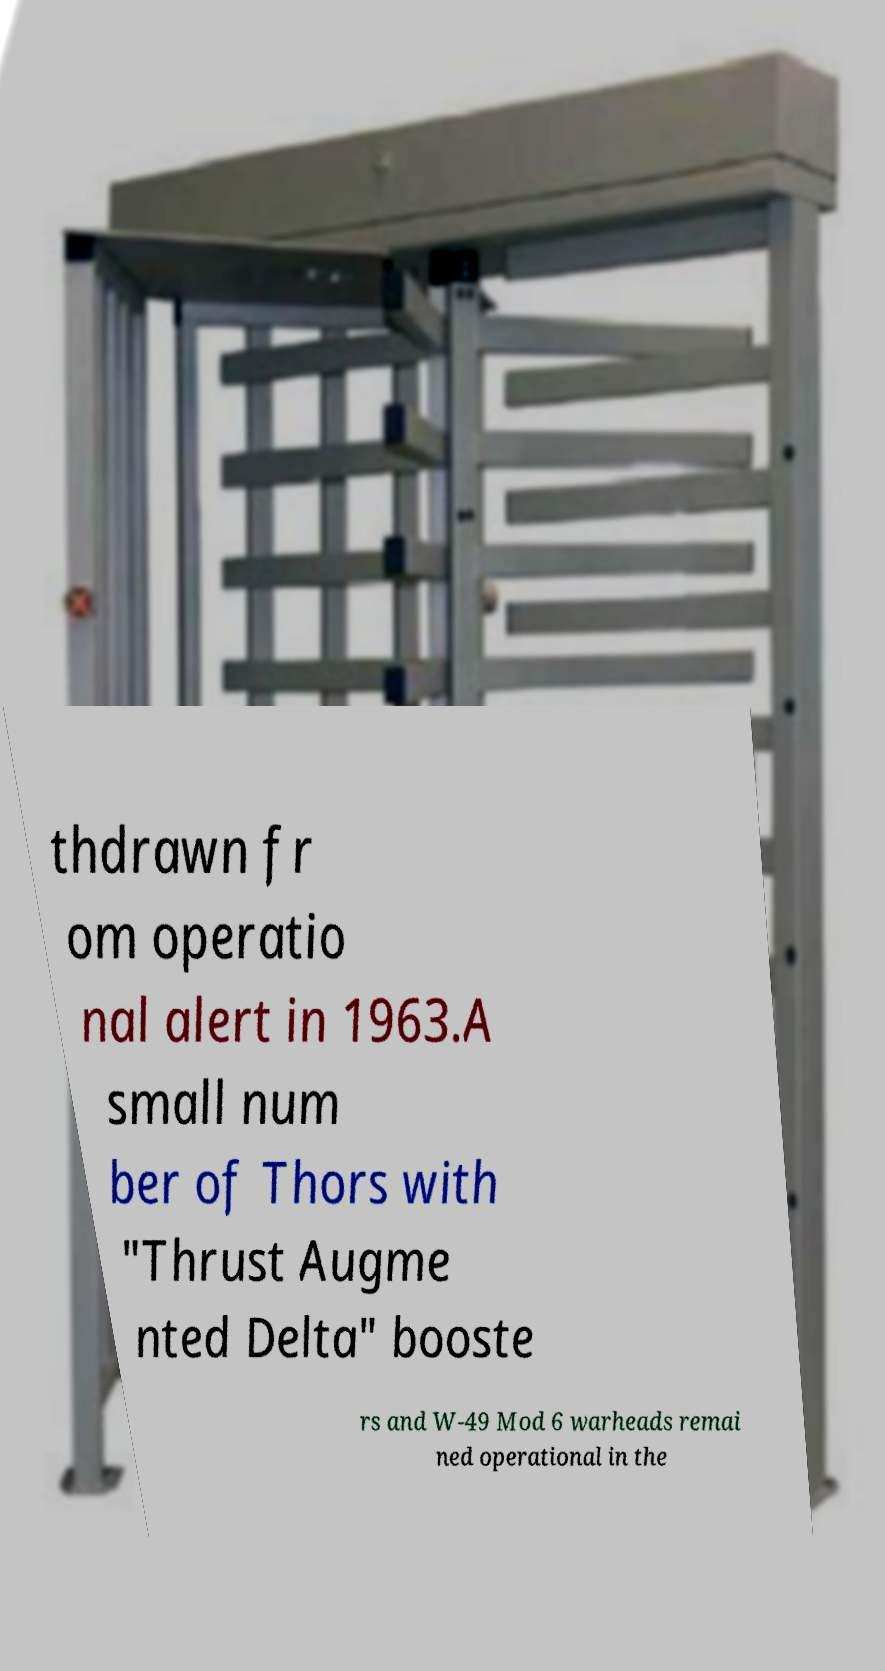Can you read and provide the text displayed in the image?This photo seems to have some interesting text. Can you extract and type it out for me? thdrawn fr om operatio nal alert in 1963.A small num ber of Thors with "Thrust Augme nted Delta" booste rs and W-49 Mod 6 warheads remai ned operational in the 